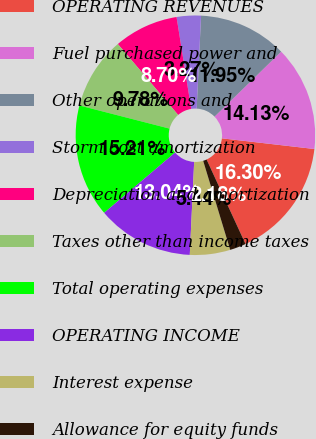Convert chart to OTSL. <chart><loc_0><loc_0><loc_500><loc_500><pie_chart><fcel>OPERATING REVENUES<fcel>Fuel purchased power and<fcel>Other operations and<fcel>Storm cost amortization<fcel>Depreciation and amortization<fcel>Taxes other than income taxes<fcel>Total operating expenses<fcel>OPERATING INCOME<fcel>Interest expense<fcel>Allowance for equity funds<nl><fcel>16.3%<fcel>14.13%<fcel>11.95%<fcel>3.27%<fcel>8.7%<fcel>9.78%<fcel>15.21%<fcel>13.04%<fcel>5.44%<fcel>2.18%<nl></chart> 